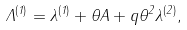<formula> <loc_0><loc_0><loc_500><loc_500>\Lambda ^ { ( 1 ) } = \lambda ^ { ( 1 ) } + \theta A + q \theta ^ { 2 } \lambda ^ { ( 2 ) } ,</formula> 